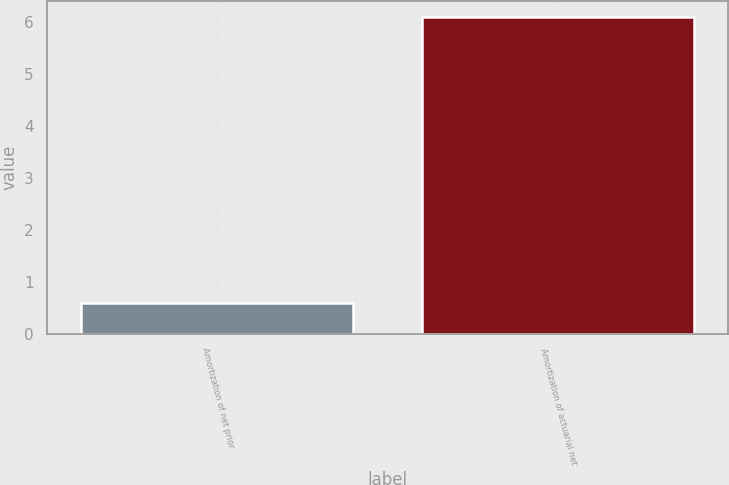Convert chart. <chart><loc_0><loc_0><loc_500><loc_500><bar_chart><fcel>Amortization of net prior<fcel>Amortization of actuarial net<nl><fcel>0.6<fcel>6.1<nl></chart> 